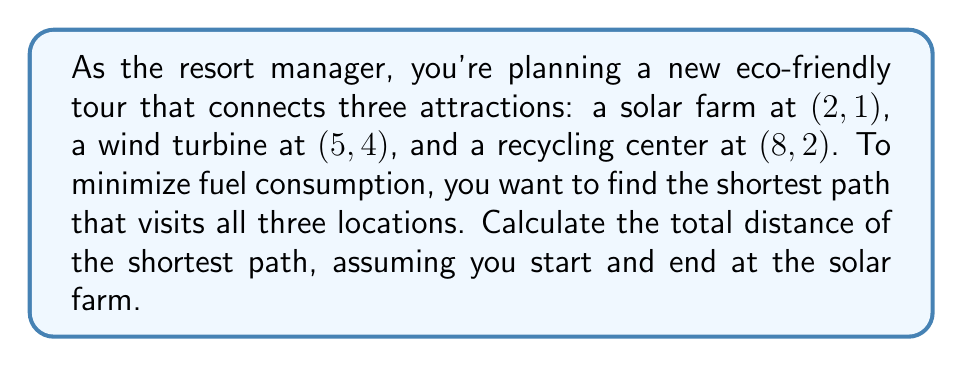Provide a solution to this math problem. To solve this problem, we need to use the distance formula and compare the possible paths:

1) First, let's calculate the distances between each pair of points using the distance formula:
   $d = \sqrt{(x_2-x_1)^2 + (y_2-y_1)^2}$

   Solar Farm (S) to Wind Turbine (W):
   $$d_{SW} = \sqrt{(5-2)^2 + (4-1)^2} = \sqrt{9 + 9} = \sqrt{18} = 3\sqrt{2}$$

   Solar Farm (S) to Recycling Center (R):
   $$d_{SR} = \sqrt{(8-2)^2 + (2-1)^2} = \sqrt{36 + 1} = \sqrt{37}$$

   Wind Turbine (W) to Recycling Center (R):
   $$d_{WR} = \sqrt{(8-5)^2 + (2-4)^2} = \sqrt{9 + 4} = \sqrt{13}$$

2) Now, we need to consider two possible paths:
   Path 1: S → W → R → S
   Path 2: S → R → W → S

3) Calculate the total distance for each path:
   Path 1: $d_{SW} + d_{WR} + d_{SR} = 3\sqrt{2} + \sqrt{13} + \sqrt{37}$
   Path 2: $d_{SR} + d_{WR} + d_{SW} = \sqrt{37} + \sqrt{13} + 3\sqrt{2}$

4) We can see that both paths have the same total distance. This is because the order of visiting W and R doesn't matter when starting and ending at S.

5) Therefore, the shortest path distance is:
   $$3\sqrt{2} + \sqrt{13} + \sqrt{37}$$

[asy]
import geometry;

unitsize(1cm);

pair S = (2,1);
pair W = (5,4);
pair R = (8,2);

dot("S", S, SW);
dot("W", W, NE);
dot("R", R, SE);

draw(S--W--R--S, arrow=Arrow(TeXHead));

label("Solar Farm", S, S);
label("Wind Turbine", W, N);
label("Recycling Center", R, E);
[/asy]
Answer: The total distance of the shortest path is $3\sqrt{2} + \sqrt{13} + \sqrt{37}$ units. 